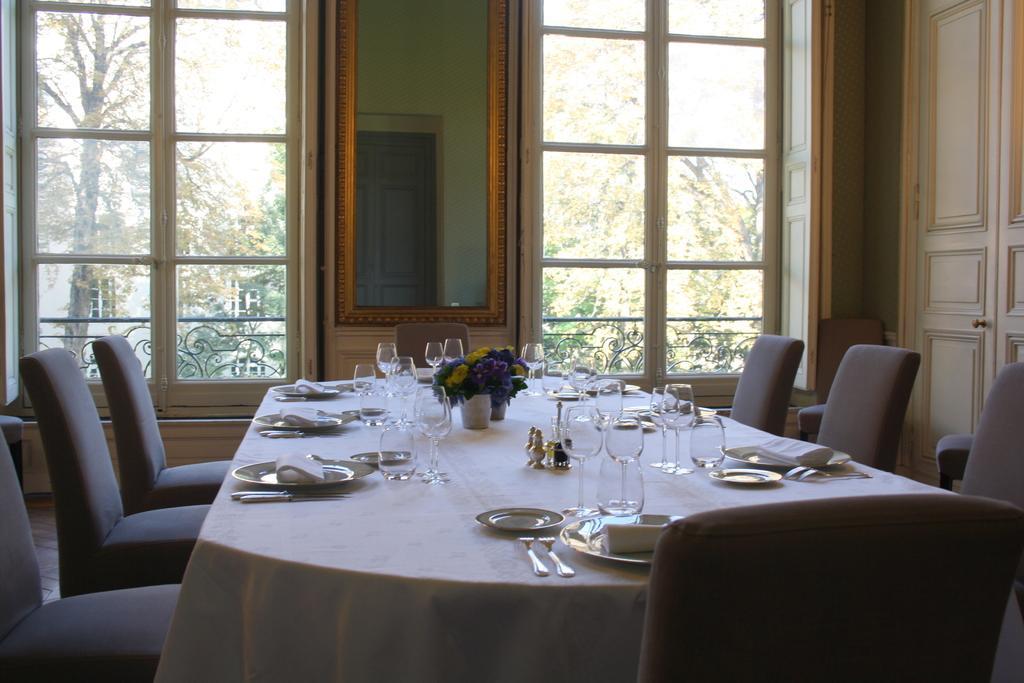In one or two sentences, can you explain what this image depicts? In the foreground I can see a dining table on which plates, glasses, spoons, tissue paper, flower vases are kept and chairs on the floor. In the background I can see windows, mirror, door, fence, trees, buildings and the sky. This image is taken may be in a hall. 